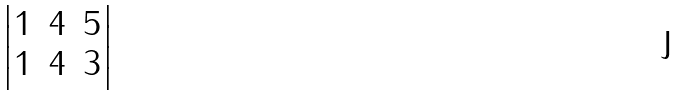<formula> <loc_0><loc_0><loc_500><loc_500>\begin{vmatrix} 1 & 4 & 5 \\ 1 & 4 & 3 \end{vmatrix}</formula> 